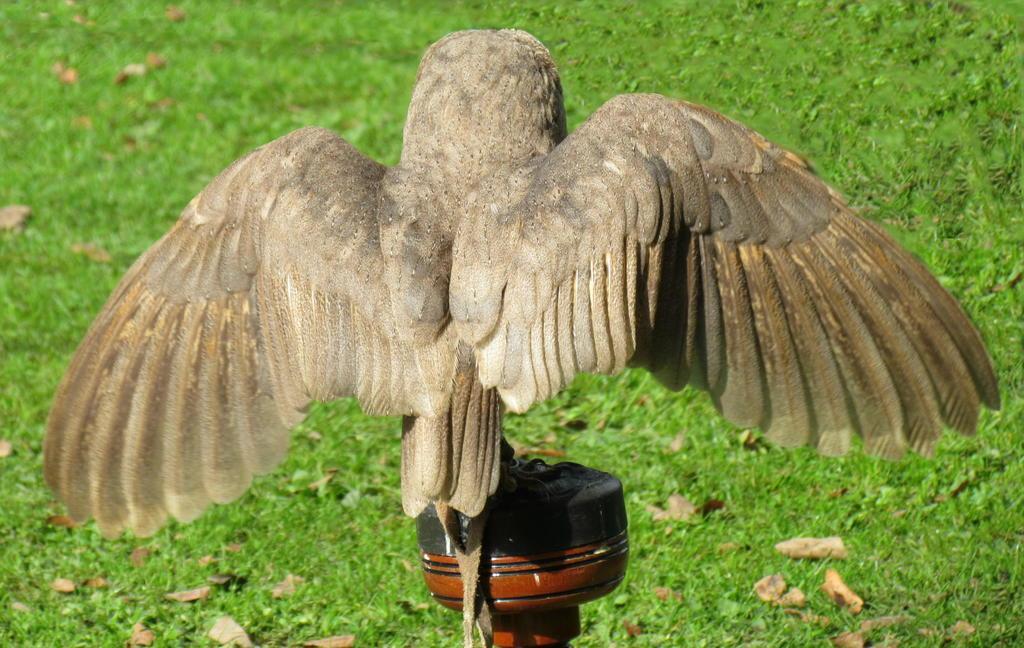In one or two sentences, can you explain what this image depicts? There is a bird standing on this black color pole on the ground. The bird is in cream color. There are some dried leaves on the ground. We can observe some grass here. 